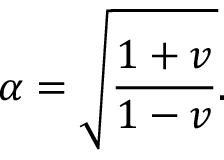<formula> <loc_0><loc_0><loc_500><loc_500>\alpha = \sqrt { \frac { 1 + v } { 1 - v } } .</formula> 